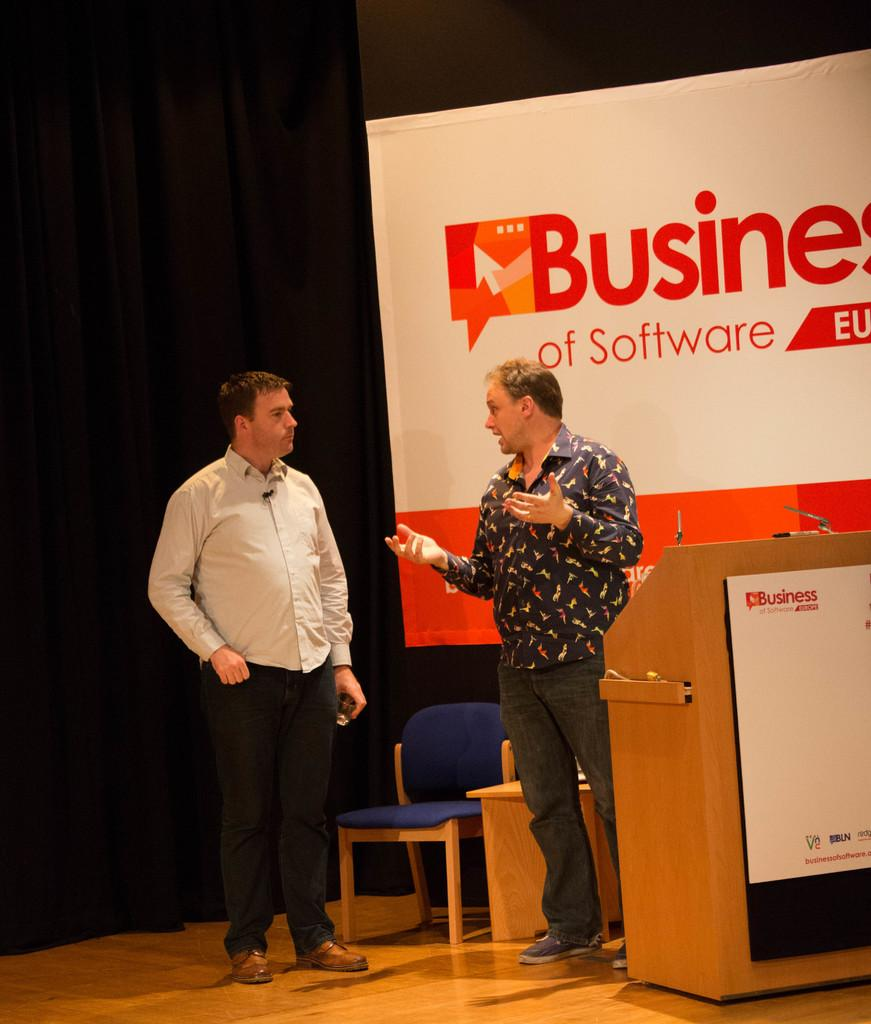How many people are in the image? There are two men in the image. What are the two men doing in the image? The two men are standing. What type of attention is the aunt receiving from the men in the image? There is no aunt present in the image, so it is not possible to determine what type of attention the men might be giving her. 